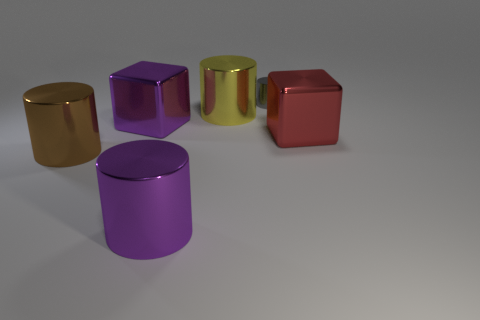Is there anything else that is the same size as the gray cylinder?
Your answer should be very brief. No. What number of red metallic objects have the same size as the brown cylinder?
Provide a short and direct response. 1. There is a cube behind the large red metal cube; is it the same size as the purple metal thing that is in front of the large red object?
Ensure brevity in your answer.  Yes. What shape is the large metallic thing right of the tiny thing?
Your response must be concise. Cube. What material is the large block left of the large metallic thing right of the gray metallic cylinder?
Make the answer very short. Metal. Is there another metallic cylinder of the same color as the tiny cylinder?
Provide a succinct answer. No. There is a purple metal block; does it have the same size as the shiny object that is behind the big yellow thing?
Ensure brevity in your answer.  No. There is a big block on the right side of the gray metallic object that is on the right side of the yellow metallic thing; how many big purple metallic things are on the right side of it?
Keep it short and to the point. 0. There is a brown cylinder; how many brown cylinders are in front of it?
Offer a very short reply. 0. What is the color of the metal block that is in front of the metal cube that is on the left side of the tiny gray metallic thing?
Offer a very short reply. Red. 